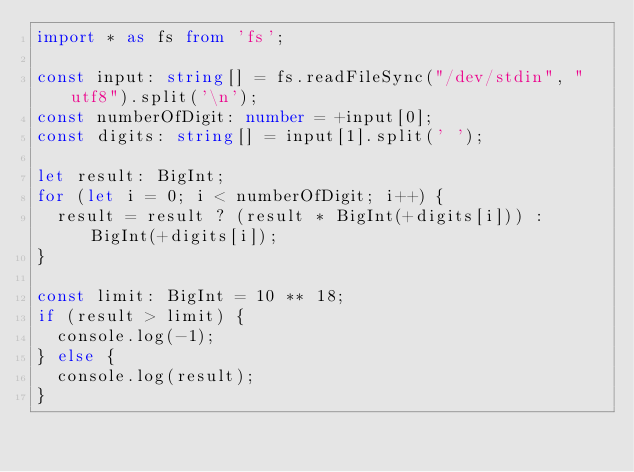<code> <loc_0><loc_0><loc_500><loc_500><_TypeScript_>import * as fs from 'fs';

const input: string[] = fs.readFileSync("/dev/stdin", "utf8").split('\n');
const numberOfDigit: number = +input[0];
const digits: string[] = input[1].split(' ');

let result: BigInt;
for (let i = 0; i < numberOfDigit; i++) {
  result = result ? (result * BigInt(+digits[i])) : BigInt(+digits[i]);
}

const limit: BigInt = 10 ** 18;
if (result > limit) {
  console.log(-1);
} else {
  console.log(result);
}</code> 